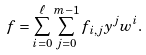Convert formula to latex. <formula><loc_0><loc_0><loc_500><loc_500>f = \sum _ { i = 0 } ^ { \ell } \sum _ { j = 0 } ^ { m - 1 } f _ { i , j } y ^ { j } w ^ { i } .</formula> 